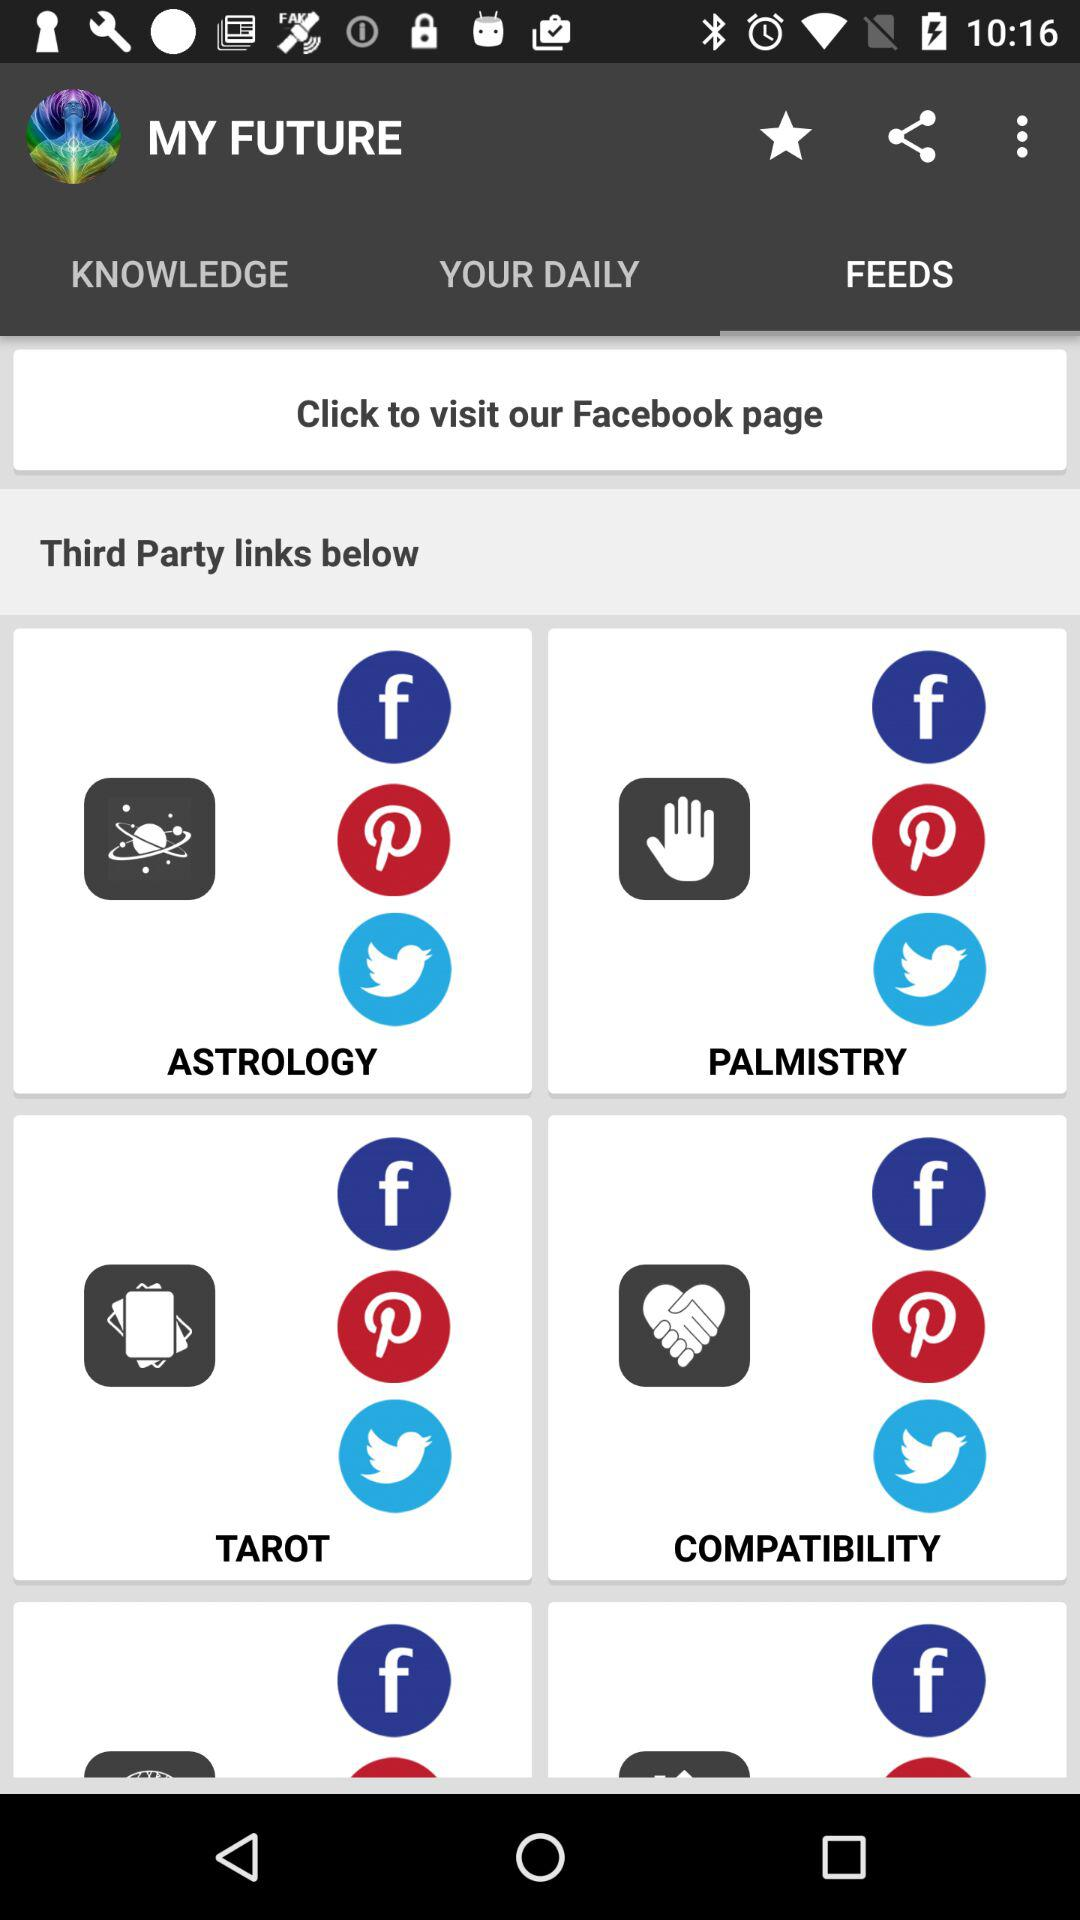Which tab is selected? The selected tab is "FEEDS". 